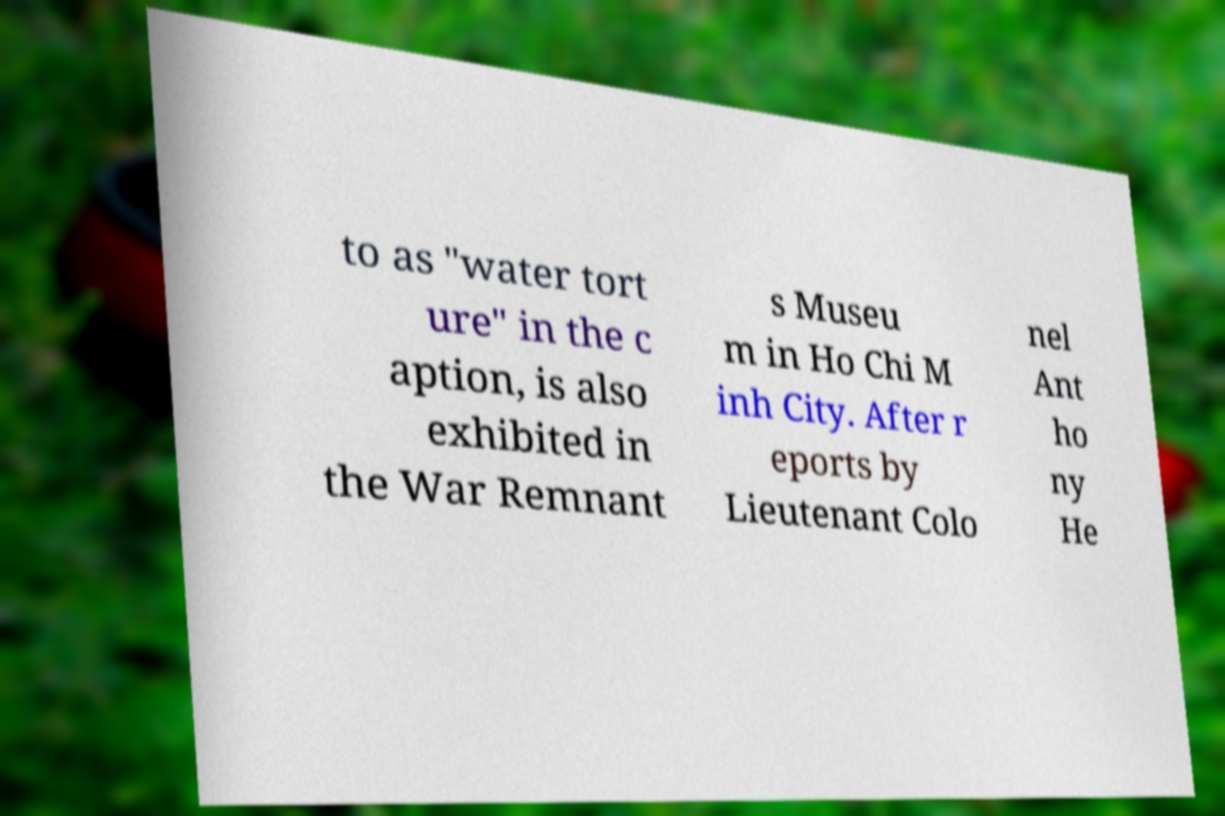For documentation purposes, I need the text within this image transcribed. Could you provide that? to as "water tort ure" in the c aption, is also exhibited in the War Remnant s Museu m in Ho Chi M inh City. After r eports by Lieutenant Colo nel Ant ho ny He 